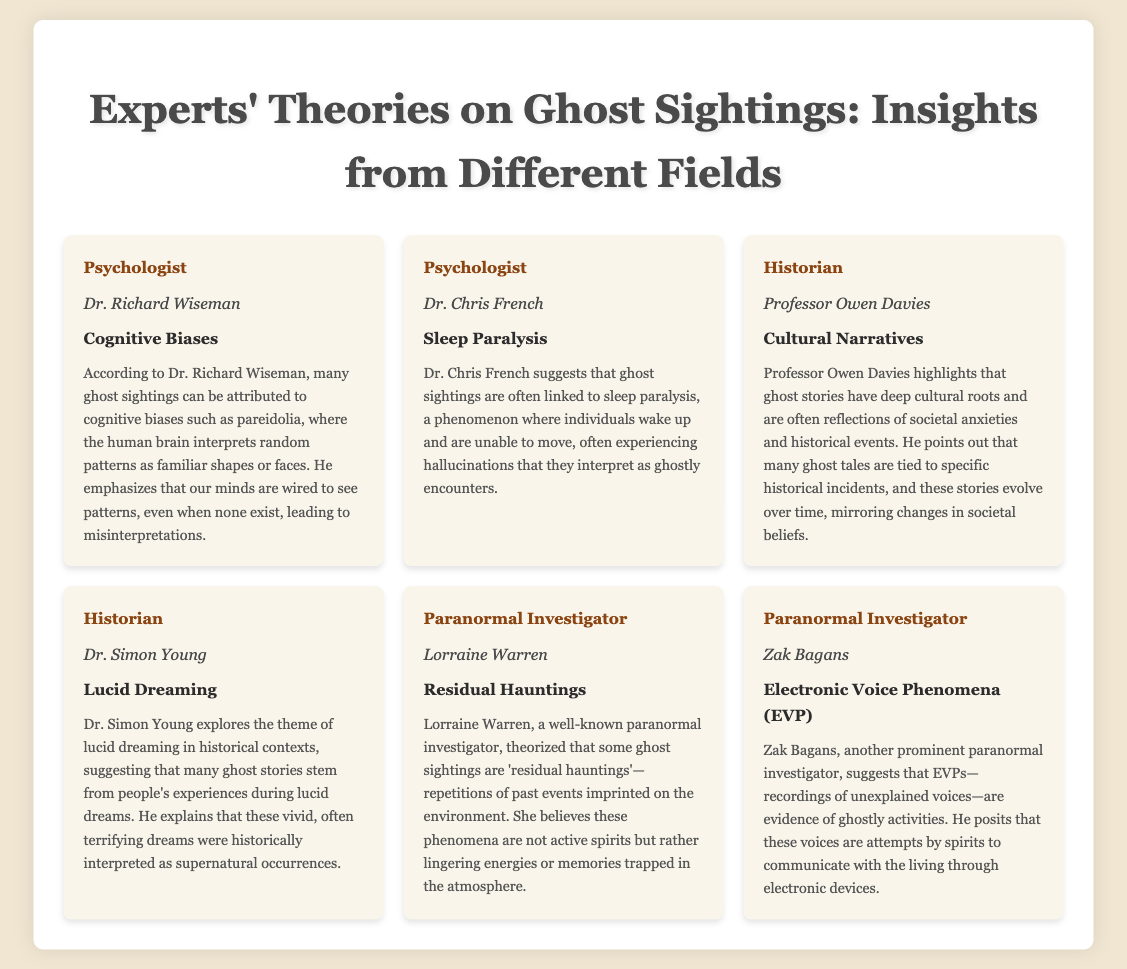What is the name of the psychologist who discusses cognitive biases? The document states that Dr. Richard Wiseman discusses cognitive biases related to ghost sightings.
Answer: Dr. Richard Wiseman What type of haunting does Lorraine Warren theorize? According to Lorraine Warren, some ghost sightings are categorized as 'residual hauntings'.
Answer: Residual hauntings What phenomenon is linked to ghost sightings according to Dr. Chris French? Dr. Chris French suggests that ghost sightings are often linked to sleep paralysis.
Answer: Sleep paralysis Who highlights the role of cultural narratives in ghost stories? Professor Owen Davies is noted in the document as highlighting the role of cultural narratives in ghost stories.
Answer: Professor Owen Davies What acronym refers to recordings of unexplained voices? The document references Electronic Voice Phenomena using the acronym EVP.
Answer: EVP According to Dr. Simon Young, what term describes vivid experiences interpreted as supernatural? Dr. Simon Young discusses lucid dreaming as experiences interpreted as supernatural occurrences.
Answer: Lucid dreaming How many psychologists are mentioned in the document? The document lists two psychologists who provide insights on ghost sightings.
Answer: Two What does Zak Bagans suggest is evidence of ghostly activities? Zak Bagans suggests that EVPs (Electronic Voice Phenomena) are evidence of ghostly activities in his theory.
Answer: EVPs What is a key factor that influences ghost stories according to historians? The document states that historical events and societal anxieties are key factors influencing ghost stories according to historians.
Answer: Historical events and societal anxieties 